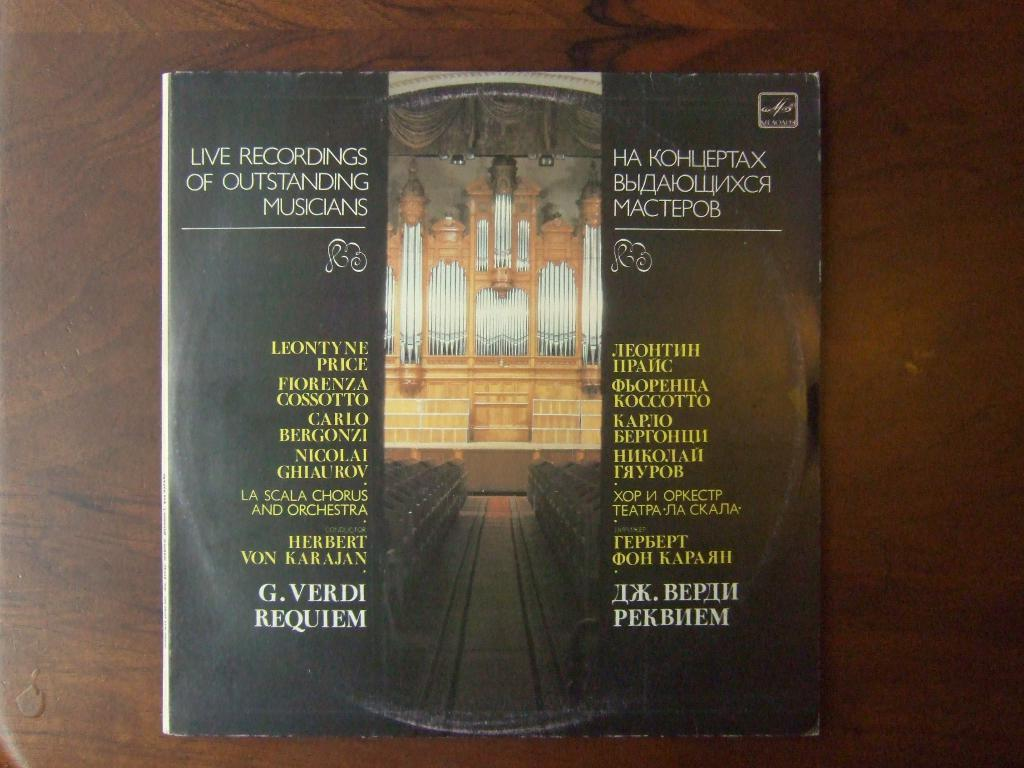Provide a one-sentence caption for the provided image. A record has live recordings of several musicians. 